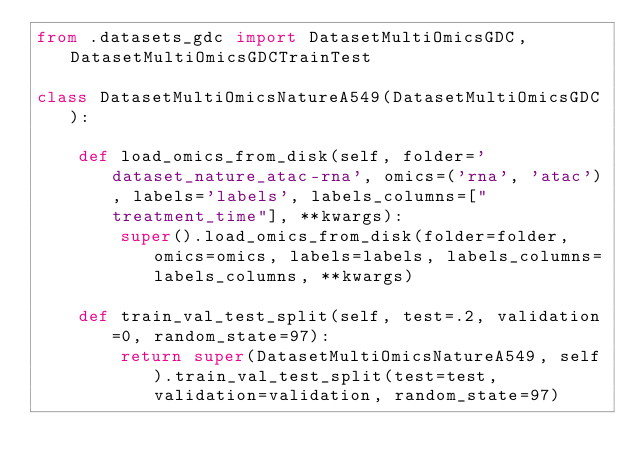Convert code to text. <code><loc_0><loc_0><loc_500><loc_500><_Python_>from .datasets_gdc import DatasetMultiOmicsGDC, DatasetMultiOmicsGDCTrainTest

class DatasetMultiOmicsNatureA549(DatasetMultiOmicsGDC):

    def load_omics_from_disk(self, folder='dataset_nature_atac-rna', omics=('rna', 'atac'), labels='labels', labels_columns=["treatment_time"], **kwargs):
        super().load_omics_from_disk(folder=folder, omics=omics, labels=labels, labels_columns=labels_columns, **kwargs)
    
    def train_val_test_split(self, test=.2, validation=0, random_state=97):
        return super(DatasetMultiOmicsNatureA549, self).train_val_test_split(test=test, validation=validation, random_state=97)</code> 